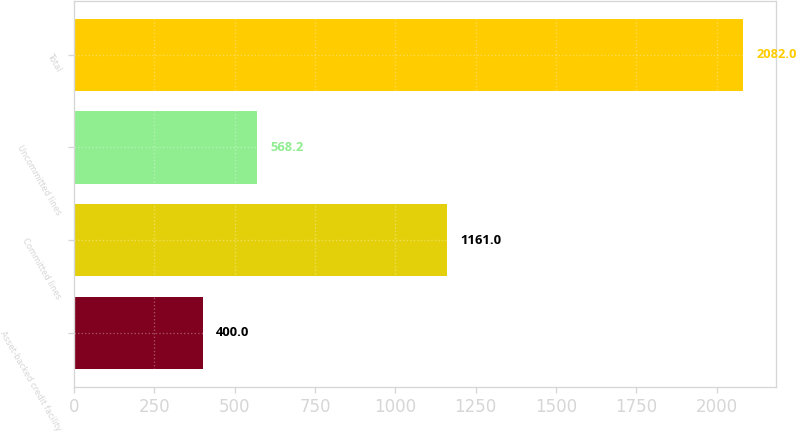<chart> <loc_0><loc_0><loc_500><loc_500><bar_chart><fcel>Asset-backed credit facility<fcel>Committed lines<fcel>Uncommitted lines<fcel>Total<nl><fcel>400<fcel>1161<fcel>568.2<fcel>2082<nl></chart> 